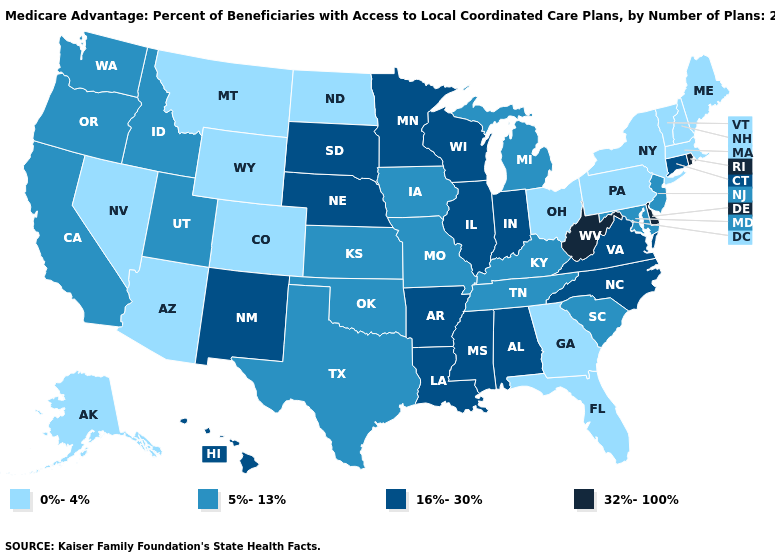Does West Virginia have the highest value in the South?
Short answer required. Yes. Name the states that have a value in the range 5%-13%?
Give a very brief answer. California, Iowa, Idaho, Kansas, Kentucky, Maryland, Michigan, Missouri, New Jersey, Oklahoma, Oregon, South Carolina, Tennessee, Texas, Utah, Washington. Name the states that have a value in the range 0%-4%?
Give a very brief answer. Alaska, Arizona, Colorado, Florida, Georgia, Massachusetts, Maine, Montana, North Dakota, New Hampshire, Nevada, New York, Ohio, Pennsylvania, Vermont, Wyoming. What is the highest value in the MidWest ?
Quick response, please. 16%-30%. Which states have the lowest value in the USA?
Answer briefly. Alaska, Arizona, Colorado, Florida, Georgia, Massachusetts, Maine, Montana, North Dakota, New Hampshire, Nevada, New York, Ohio, Pennsylvania, Vermont, Wyoming. Does Maine have the lowest value in the USA?
Concise answer only. Yes. What is the lowest value in the MidWest?
Short answer required. 0%-4%. Does the map have missing data?
Be succinct. No. Name the states that have a value in the range 5%-13%?
Concise answer only. California, Iowa, Idaho, Kansas, Kentucky, Maryland, Michigan, Missouri, New Jersey, Oklahoma, Oregon, South Carolina, Tennessee, Texas, Utah, Washington. Which states have the lowest value in the USA?
Concise answer only. Alaska, Arizona, Colorado, Florida, Georgia, Massachusetts, Maine, Montana, North Dakota, New Hampshire, Nevada, New York, Ohio, Pennsylvania, Vermont, Wyoming. Does Florida have the lowest value in the South?
Be succinct. Yes. Is the legend a continuous bar?
Short answer required. No. Name the states that have a value in the range 32%-100%?
Answer briefly. Delaware, Rhode Island, West Virginia. What is the value of North Dakota?
Short answer required. 0%-4%. What is the value of Virginia?
Be succinct. 16%-30%. 